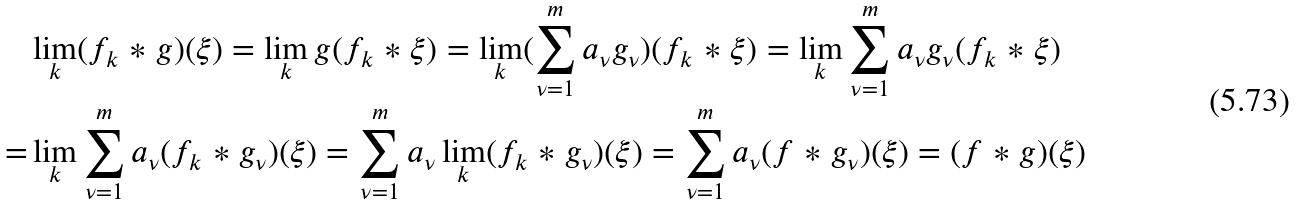<formula> <loc_0><loc_0><loc_500><loc_500>& \lim _ { k } ( f _ { k } \ast g ) ( \xi ) = \lim _ { k } g ( f _ { k } \ast \xi ) = \lim _ { k } ( \sum _ { \nu = 1 } ^ { m } a _ { \nu } g _ { \nu } ) ( f _ { k } \ast \xi ) = \lim _ { k } \sum _ { \nu = 1 } ^ { m } a _ { \nu } g _ { \nu } ( f _ { k } \ast \xi ) \\ = & \lim _ { k } \sum _ { \nu = 1 } ^ { m } a _ { \nu } ( f _ { k } \ast g _ { \nu } ) ( \xi ) = \sum _ { \nu = 1 } ^ { m } a _ { \nu } \lim _ { k } ( f _ { k } \ast g _ { \nu } ) ( \xi ) = \sum _ { \nu = 1 } ^ { m } a _ { \nu } ( f \ast g _ { \nu } ) ( \xi ) = ( f \ast g ) ( \xi )</formula> 